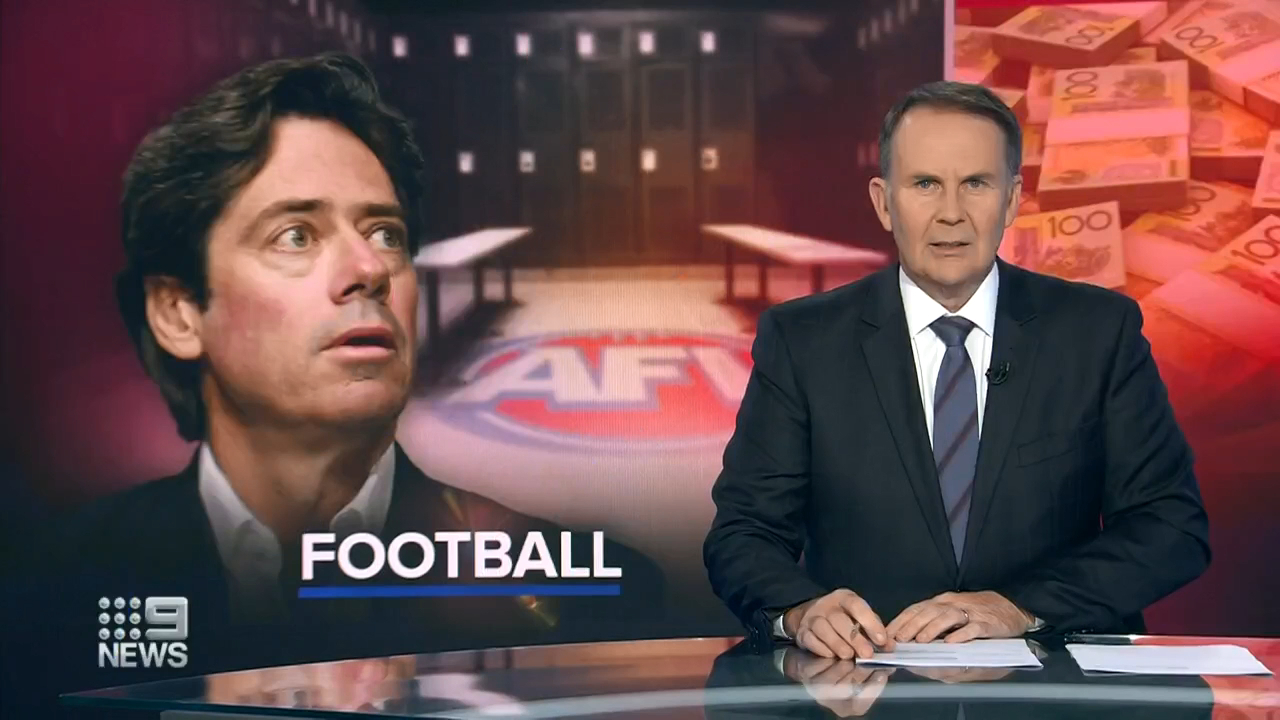How might the current mood affect the players and their performance? If the news segment is reflecting a serious confluence of issues within Australian Football, this can lead to a tremendous psychological impact on the players. The stress of financial instability and possible controversies could weigh heavily on their mental well-being, potentially leading to diminished on-field performance. Players might feel insecure about their careers and futures, which can manifest as lack of focus, lower morale, and increased frustration during games. The overall atmosphere within the teams could shift to one of apprehension and unease, further impacting their cohesion and effectiveness as a team. Could the financial troubles lead to any positive changes in the sport? Yes, financial troubles, while challenging, can sometimes act as a catalyst for positive change. They can drive reformations in how sports organizations manage their finances, pushing for greater transparency and accountability. This may lead to the implementation of more efficient budgeting practices and financial management systems. Additionally, there could be a heightened focus on sustainable development, ensuring that resources are allocated for the long-term growth of the sport. It might also encourage community-driven initiatives and increased fan engagement to support their teams through challenging times, fostering a stronger bond between the sport and its followers. What sort of community-driven initiatives could arise from such a situation? In response to financial troubles in Australian Football, several community-driven initiatives could emerge to support the sport. These might include crowdfunding campaigns where fans contribute to keep smaller teams afloat, local businesses sponsoring grassroots programs, and volunteers offering their time and skills to help manage events and training sessions. There's potential for community events designed to raise funds and awareness, creating a sense of unity and shared purpose. Fan clubs could organize charity matches, merch sales, and community outreach programs to boost engagement and support for the teams. 